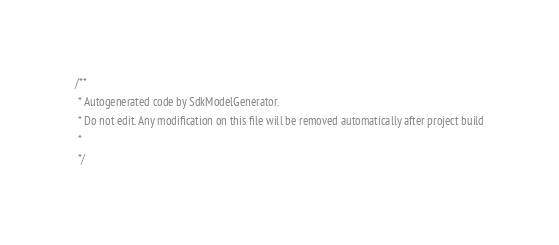<code> <loc_0><loc_0><loc_500><loc_500><_Java_>/**
 * Autogenerated code by SdkModelGenerator.
 * Do not edit. Any modification on this file will be removed automatically after project build
 *
 */</code> 